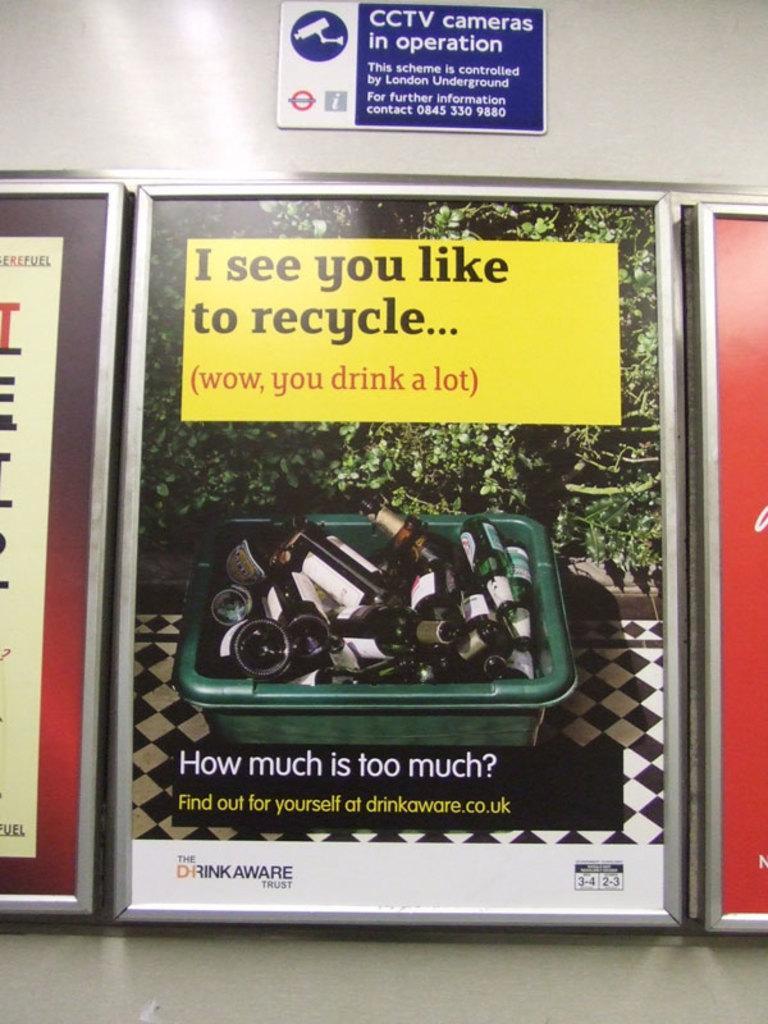Describe this image in one or two sentences. It is a banner of an image, in this there are beer bottles in a plastic tub and few other plants are there. 